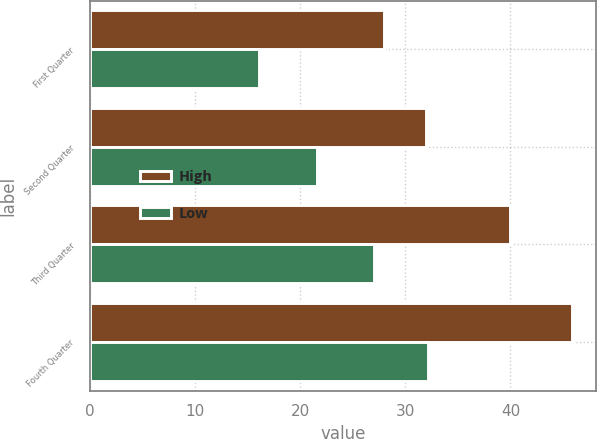Convert chart. <chart><loc_0><loc_0><loc_500><loc_500><stacked_bar_chart><ecel><fcel>First Quarter<fcel>Second Quarter<fcel>Third Quarter<fcel>Fourth Quarter<nl><fcel>High<fcel>27.98<fcel>32<fcel>40<fcel>45.87<nl><fcel>Low<fcel>16.1<fcel>21.6<fcel>27.02<fcel>32.2<nl></chart> 